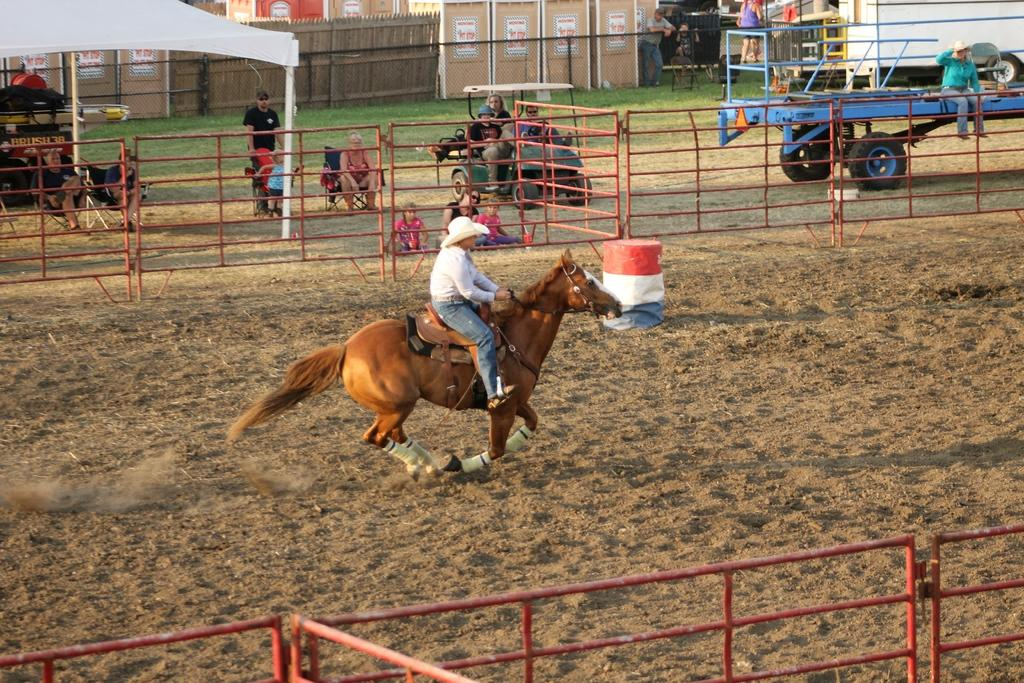What is the person in the image doing? The person is riding a horse in the image. What type of terrain can be seen in the image? There is sand and green grass visible in the image. What kind of fencing is present in the image? There is a metal grill fence and a wooden fence in the image. How many people are sitting in the image? There are a few people sitting in the image. What type of blade is being used by the person riding the horse in the image? There is no blade visible in the image; the person is riding a horse without any apparent tools or weapons. 